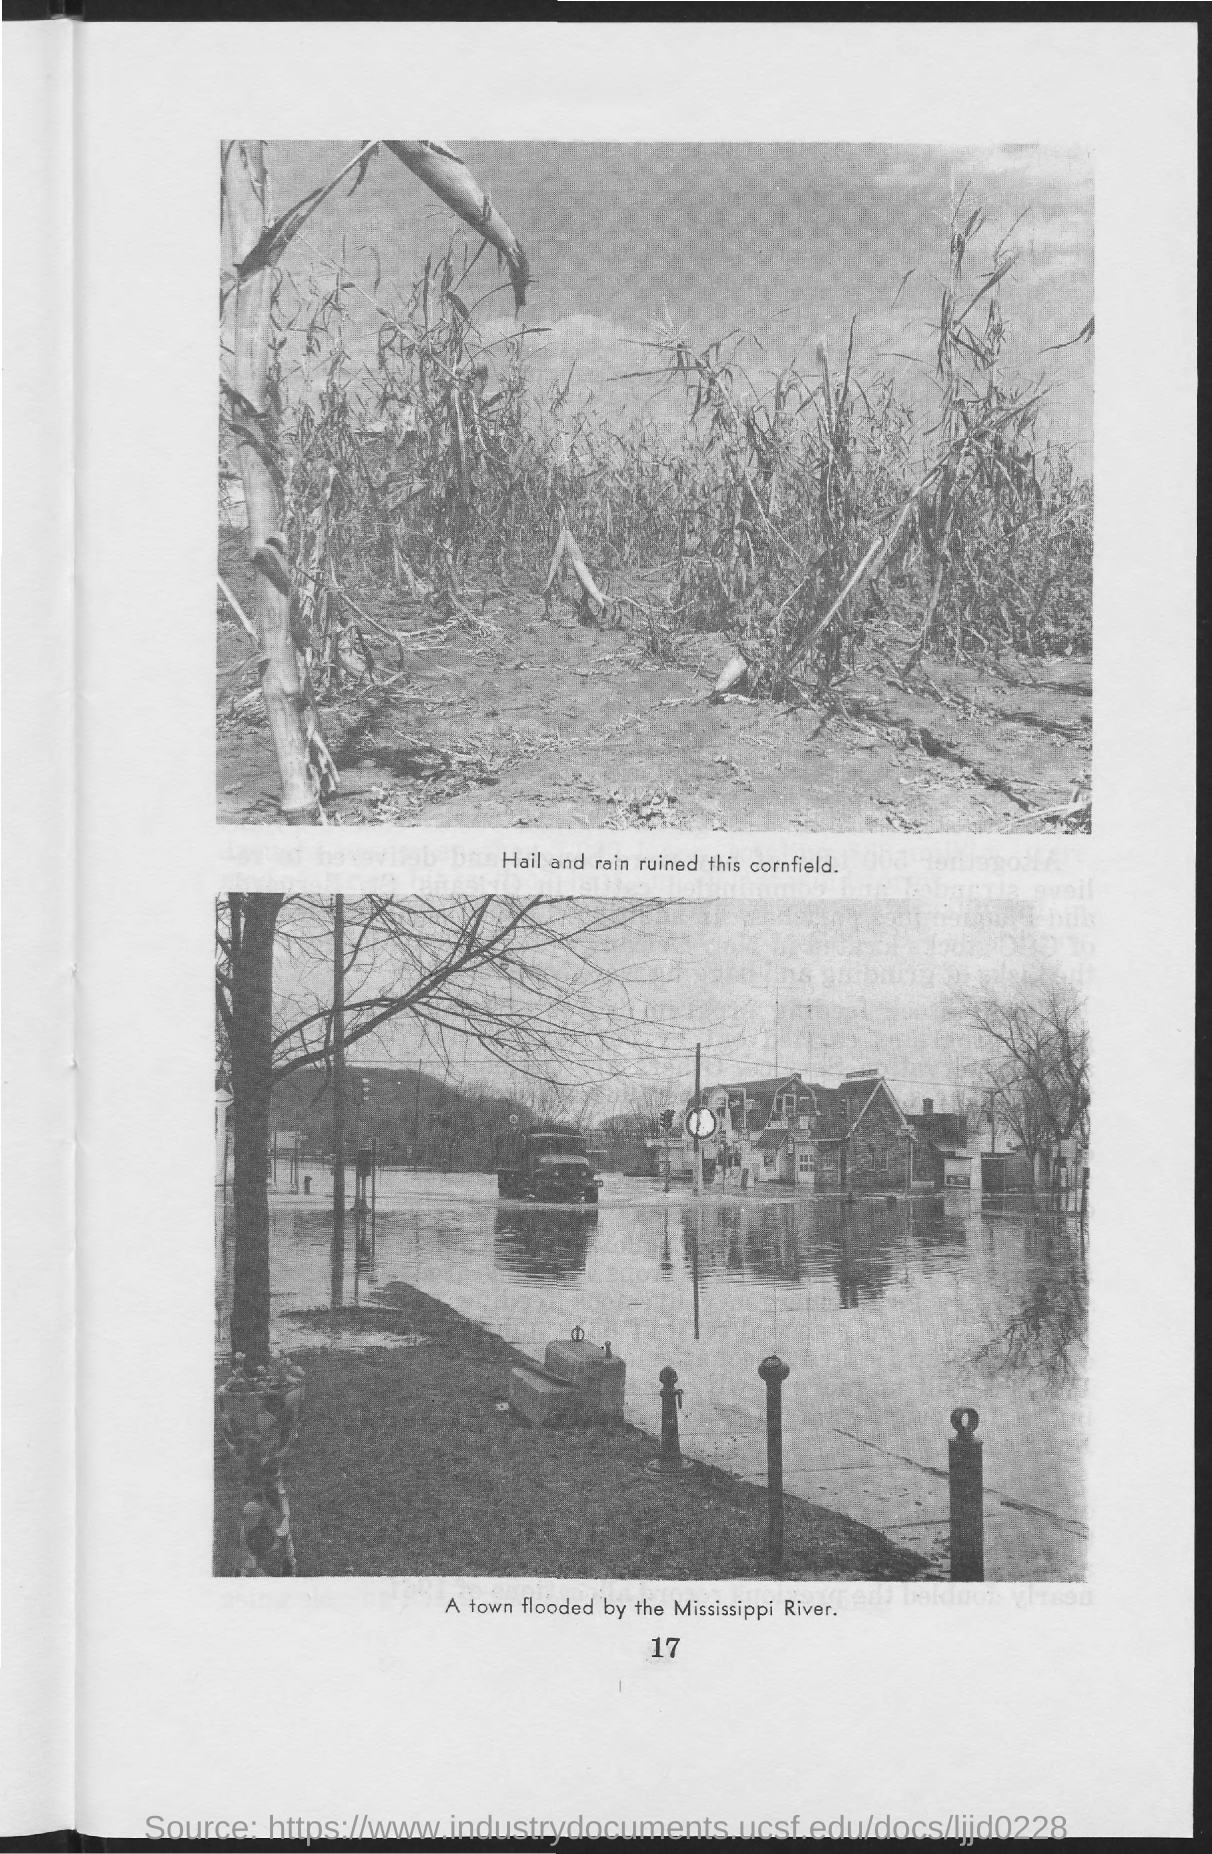Indicate a few pertinent items in this graphic. The second image in this document represents a town that has been flooded by the Mississippi River. The first image in this document signifies the destruction caused by hail and rain on a cornfield. The page number mentioned in this document is 17. 